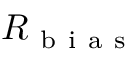<formula> <loc_0><loc_0><loc_500><loc_500>R _ { b i a s }</formula> 